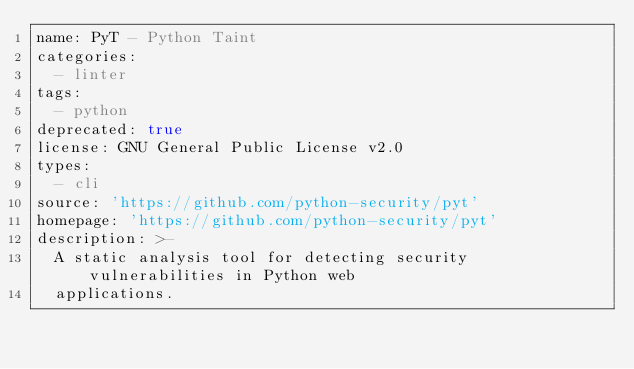Convert code to text. <code><loc_0><loc_0><loc_500><loc_500><_YAML_>name: PyT - Python Taint
categories:
  - linter
tags:
  - python
deprecated: true
license: GNU General Public License v2.0
types:
  - cli
source: 'https://github.com/python-security/pyt'
homepage: 'https://github.com/python-security/pyt'
description: >-
  A static analysis tool for detecting security vulnerabilities in Python web
  applications.
</code> 